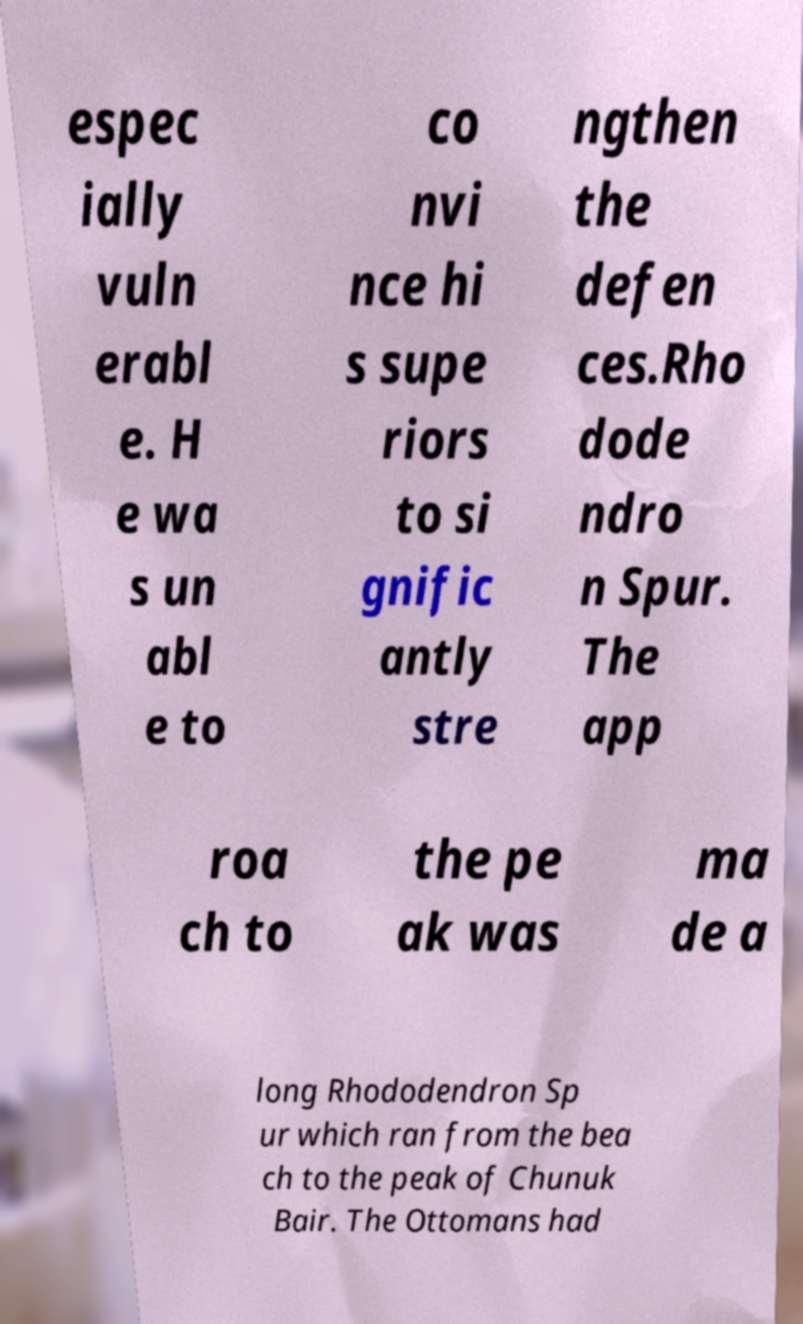Please identify and transcribe the text found in this image. espec ially vuln erabl e. H e wa s un abl e to co nvi nce hi s supe riors to si gnific antly stre ngthen the defen ces.Rho dode ndro n Spur. The app roa ch to the pe ak was ma de a long Rhododendron Sp ur which ran from the bea ch to the peak of Chunuk Bair. The Ottomans had 